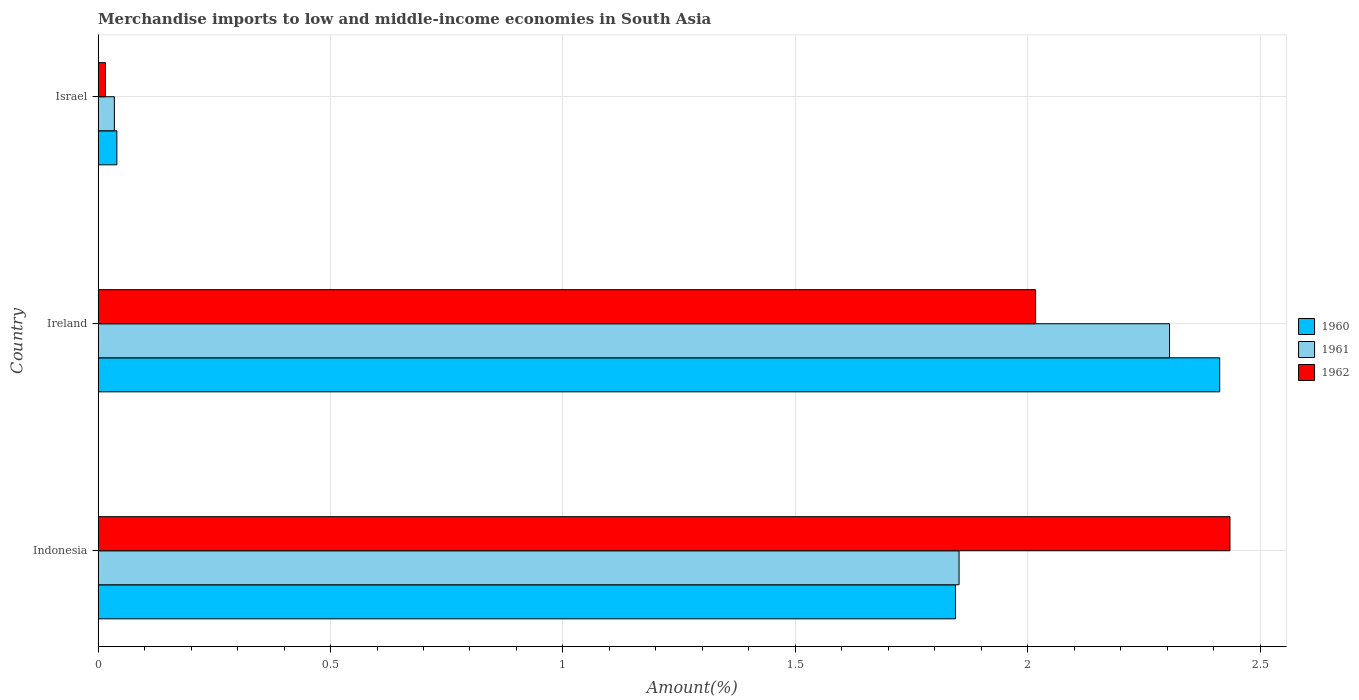How many groups of bars are there?
Make the answer very short. 3. Are the number of bars per tick equal to the number of legend labels?
Your response must be concise. Yes. Are the number of bars on each tick of the Y-axis equal?
Provide a succinct answer. Yes. What is the label of the 2nd group of bars from the top?
Keep it short and to the point. Ireland. In how many cases, is the number of bars for a given country not equal to the number of legend labels?
Provide a short and direct response. 0. What is the percentage of amount earned from merchandise imports in 1962 in Ireland?
Provide a succinct answer. 2.02. Across all countries, what is the maximum percentage of amount earned from merchandise imports in 1962?
Offer a terse response. 2.44. Across all countries, what is the minimum percentage of amount earned from merchandise imports in 1960?
Give a very brief answer. 0.04. In which country was the percentage of amount earned from merchandise imports in 1960 minimum?
Your response must be concise. Israel. What is the total percentage of amount earned from merchandise imports in 1962 in the graph?
Your answer should be compact. 4.47. What is the difference between the percentage of amount earned from merchandise imports in 1962 in Indonesia and that in Israel?
Your answer should be compact. 2.42. What is the difference between the percentage of amount earned from merchandise imports in 1960 in Israel and the percentage of amount earned from merchandise imports in 1961 in Indonesia?
Offer a very short reply. -1.81. What is the average percentage of amount earned from merchandise imports in 1962 per country?
Provide a succinct answer. 1.49. What is the difference between the percentage of amount earned from merchandise imports in 1961 and percentage of amount earned from merchandise imports in 1962 in Israel?
Provide a succinct answer. 0.02. What is the ratio of the percentage of amount earned from merchandise imports in 1961 in Ireland to that in Israel?
Provide a succinct answer. 65.96. Is the percentage of amount earned from merchandise imports in 1962 in Indonesia less than that in Israel?
Provide a short and direct response. No. What is the difference between the highest and the second highest percentage of amount earned from merchandise imports in 1962?
Offer a terse response. 0.42. What is the difference between the highest and the lowest percentage of amount earned from merchandise imports in 1961?
Offer a very short reply. 2.27. What does the 3rd bar from the bottom in Ireland represents?
Make the answer very short. 1962. Is it the case that in every country, the sum of the percentage of amount earned from merchandise imports in 1962 and percentage of amount earned from merchandise imports in 1961 is greater than the percentage of amount earned from merchandise imports in 1960?
Your response must be concise. Yes. How many bars are there?
Keep it short and to the point. 9. Are all the bars in the graph horizontal?
Provide a succinct answer. Yes. How many countries are there in the graph?
Offer a terse response. 3. What is the difference between two consecutive major ticks on the X-axis?
Offer a terse response. 0.5. Are the values on the major ticks of X-axis written in scientific E-notation?
Keep it short and to the point. No. Does the graph contain any zero values?
Provide a succinct answer. No. Where does the legend appear in the graph?
Offer a very short reply. Center right. How are the legend labels stacked?
Your answer should be very brief. Vertical. What is the title of the graph?
Your response must be concise. Merchandise imports to low and middle-income economies in South Asia. What is the label or title of the X-axis?
Offer a very short reply. Amount(%). What is the label or title of the Y-axis?
Provide a succinct answer. Country. What is the Amount(%) in 1960 in Indonesia?
Offer a terse response. 1.84. What is the Amount(%) in 1961 in Indonesia?
Provide a short and direct response. 1.85. What is the Amount(%) of 1962 in Indonesia?
Give a very brief answer. 2.44. What is the Amount(%) in 1960 in Ireland?
Provide a succinct answer. 2.41. What is the Amount(%) of 1961 in Ireland?
Your response must be concise. 2.31. What is the Amount(%) of 1962 in Ireland?
Offer a terse response. 2.02. What is the Amount(%) of 1960 in Israel?
Make the answer very short. 0.04. What is the Amount(%) in 1961 in Israel?
Offer a very short reply. 0.03. What is the Amount(%) of 1962 in Israel?
Provide a succinct answer. 0.02. Across all countries, what is the maximum Amount(%) of 1960?
Provide a short and direct response. 2.41. Across all countries, what is the maximum Amount(%) in 1961?
Give a very brief answer. 2.31. Across all countries, what is the maximum Amount(%) of 1962?
Provide a short and direct response. 2.44. Across all countries, what is the minimum Amount(%) of 1960?
Make the answer very short. 0.04. Across all countries, what is the minimum Amount(%) of 1961?
Give a very brief answer. 0.03. Across all countries, what is the minimum Amount(%) of 1962?
Give a very brief answer. 0.02. What is the total Amount(%) in 1960 in the graph?
Provide a short and direct response. 4.3. What is the total Amount(%) in 1961 in the graph?
Ensure brevity in your answer.  4.19. What is the total Amount(%) of 1962 in the graph?
Provide a short and direct response. 4.47. What is the difference between the Amount(%) of 1960 in Indonesia and that in Ireland?
Offer a terse response. -0.57. What is the difference between the Amount(%) of 1961 in Indonesia and that in Ireland?
Your response must be concise. -0.45. What is the difference between the Amount(%) of 1962 in Indonesia and that in Ireland?
Provide a succinct answer. 0.42. What is the difference between the Amount(%) of 1960 in Indonesia and that in Israel?
Provide a short and direct response. 1.8. What is the difference between the Amount(%) in 1961 in Indonesia and that in Israel?
Ensure brevity in your answer.  1.82. What is the difference between the Amount(%) in 1962 in Indonesia and that in Israel?
Offer a terse response. 2.42. What is the difference between the Amount(%) of 1960 in Ireland and that in Israel?
Keep it short and to the point. 2.37. What is the difference between the Amount(%) of 1961 in Ireland and that in Israel?
Ensure brevity in your answer.  2.27. What is the difference between the Amount(%) of 1962 in Ireland and that in Israel?
Provide a succinct answer. 2. What is the difference between the Amount(%) of 1960 in Indonesia and the Amount(%) of 1961 in Ireland?
Provide a short and direct response. -0.46. What is the difference between the Amount(%) of 1960 in Indonesia and the Amount(%) of 1962 in Ireland?
Provide a succinct answer. -0.17. What is the difference between the Amount(%) of 1961 in Indonesia and the Amount(%) of 1962 in Ireland?
Your response must be concise. -0.16. What is the difference between the Amount(%) in 1960 in Indonesia and the Amount(%) in 1961 in Israel?
Your answer should be compact. 1.81. What is the difference between the Amount(%) in 1960 in Indonesia and the Amount(%) in 1962 in Israel?
Make the answer very short. 1.83. What is the difference between the Amount(%) in 1961 in Indonesia and the Amount(%) in 1962 in Israel?
Your answer should be compact. 1.84. What is the difference between the Amount(%) of 1960 in Ireland and the Amount(%) of 1961 in Israel?
Provide a short and direct response. 2.38. What is the difference between the Amount(%) in 1960 in Ireland and the Amount(%) in 1962 in Israel?
Give a very brief answer. 2.4. What is the difference between the Amount(%) of 1961 in Ireland and the Amount(%) of 1962 in Israel?
Your response must be concise. 2.29. What is the average Amount(%) of 1960 per country?
Make the answer very short. 1.43. What is the average Amount(%) of 1961 per country?
Your answer should be very brief. 1.4. What is the average Amount(%) in 1962 per country?
Offer a terse response. 1.49. What is the difference between the Amount(%) in 1960 and Amount(%) in 1961 in Indonesia?
Provide a succinct answer. -0.01. What is the difference between the Amount(%) of 1960 and Amount(%) of 1962 in Indonesia?
Offer a terse response. -0.59. What is the difference between the Amount(%) in 1961 and Amount(%) in 1962 in Indonesia?
Provide a succinct answer. -0.58. What is the difference between the Amount(%) in 1960 and Amount(%) in 1961 in Ireland?
Keep it short and to the point. 0.11. What is the difference between the Amount(%) in 1960 and Amount(%) in 1962 in Ireland?
Your answer should be compact. 0.4. What is the difference between the Amount(%) in 1961 and Amount(%) in 1962 in Ireland?
Your response must be concise. 0.29. What is the difference between the Amount(%) of 1960 and Amount(%) of 1961 in Israel?
Give a very brief answer. 0.01. What is the difference between the Amount(%) of 1960 and Amount(%) of 1962 in Israel?
Make the answer very short. 0.02. What is the difference between the Amount(%) of 1961 and Amount(%) of 1962 in Israel?
Your answer should be very brief. 0.02. What is the ratio of the Amount(%) of 1960 in Indonesia to that in Ireland?
Provide a short and direct response. 0.76. What is the ratio of the Amount(%) in 1961 in Indonesia to that in Ireland?
Give a very brief answer. 0.8. What is the ratio of the Amount(%) in 1962 in Indonesia to that in Ireland?
Offer a terse response. 1.21. What is the ratio of the Amount(%) of 1960 in Indonesia to that in Israel?
Offer a terse response. 45.76. What is the ratio of the Amount(%) of 1961 in Indonesia to that in Israel?
Make the answer very short. 53. What is the ratio of the Amount(%) of 1962 in Indonesia to that in Israel?
Provide a short and direct response. 154.61. What is the ratio of the Amount(%) in 1960 in Ireland to that in Israel?
Offer a very short reply. 59.86. What is the ratio of the Amount(%) in 1961 in Ireland to that in Israel?
Offer a terse response. 65.96. What is the ratio of the Amount(%) of 1962 in Ireland to that in Israel?
Your response must be concise. 128.06. What is the difference between the highest and the second highest Amount(%) of 1960?
Offer a very short reply. 0.57. What is the difference between the highest and the second highest Amount(%) in 1961?
Provide a succinct answer. 0.45. What is the difference between the highest and the second highest Amount(%) in 1962?
Offer a terse response. 0.42. What is the difference between the highest and the lowest Amount(%) in 1960?
Keep it short and to the point. 2.37. What is the difference between the highest and the lowest Amount(%) in 1961?
Your answer should be very brief. 2.27. What is the difference between the highest and the lowest Amount(%) in 1962?
Your response must be concise. 2.42. 